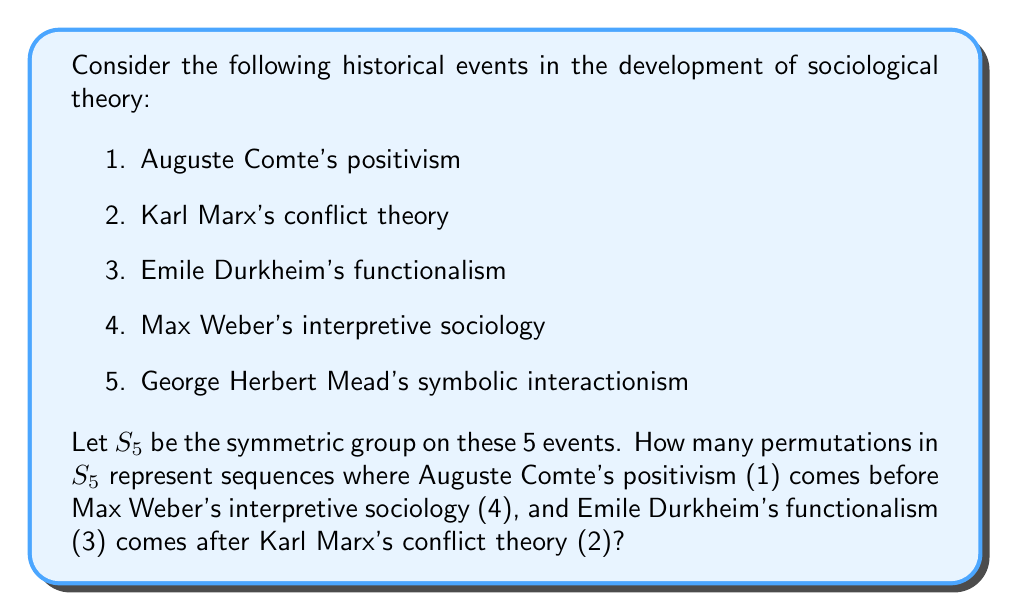Show me your answer to this math problem. To solve this problem, we need to use the concept of permutation groups and counting principles. Let's approach this step-by-step:

1) First, we need to understand what the question is asking. We're looking for permutations in $S_5$ that satisfy two conditions:
   a) 1 comes before 4
   b) 3 comes after 2

2) Let's start by considering the total number of permutations in $S_5$. This is simply 5! = 120.

3) Now, we need to count the permutations that satisfy both conditions. We can do this by considering the complementary cases and subtracting from the total.

4) Let's count the permutations that violate condition (a), i.e., where 4 comes before 1:
   - We can treat 4 and 1 as a single unit in these cases.
   - We now have 4 elements to permute: (41), 2, 3, and 5.
   - The number of such permutations is 4! = 24.

5) Similarly, let's count the permutations that violate condition (b), i.e., where 3 comes before 2:
   - We can treat 3 and 2 as a single unit in these cases.
   - We again have 4 elements to permute: 1, (32), 4, and 5.
   - The number of such permutations is also 4! = 24.

6) However, we've double-counted the permutations that violate both conditions. We need to subtract these:
   - In these cases, we have 4 comes before 1, and 3 comes before 2.
   - We can treat these as three units: (41), (32), and 5.
   - The number of such permutations is 3! = 6.

7) Using the principle of inclusion-exclusion, the number of permutations satisfying both conditions is:

   $$120 - (24 + 24 - 6) = 120 - 42 = 78$$

Therefore, there are 78 permutations in $S_5$ that satisfy both conditions.
Answer: 78 